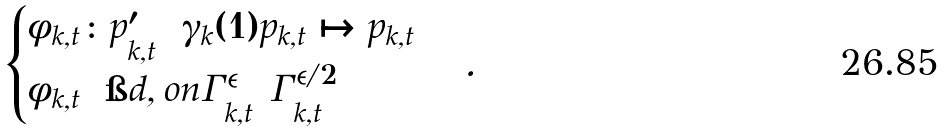Convert formula to latex. <formula><loc_0><loc_0><loc_500><loc_500>\begin{cases} \phi _ { k , t } \colon p ^ { \prime } _ { k , t } = \gamma _ { k } ( 1 ) p _ { k , t } \mapsto p _ { k , t } \\ \phi _ { k , t } = \i d , o n { \Gamma _ { k , t } ^ { \epsilon } \ \Gamma _ { k , t } ^ { \epsilon / 2 } } \end{cases} .</formula> 